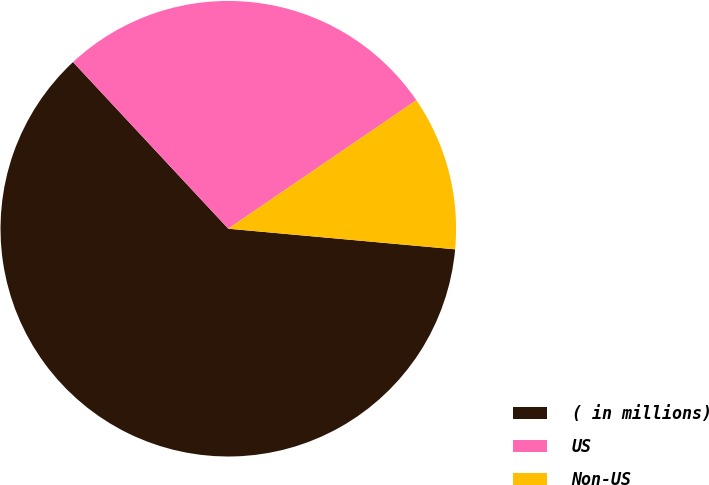<chart> <loc_0><loc_0><loc_500><loc_500><pie_chart><fcel>( in millions)<fcel>US<fcel>Non-US<nl><fcel>61.62%<fcel>27.4%<fcel>10.98%<nl></chart> 